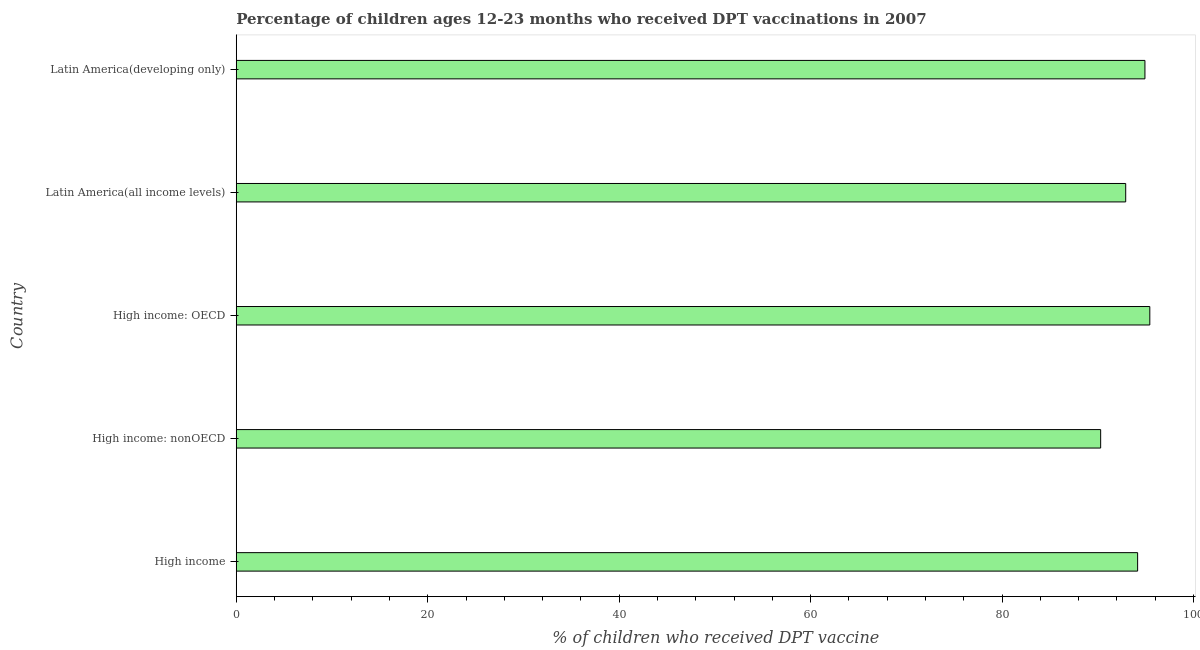Does the graph contain any zero values?
Ensure brevity in your answer.  No. Does the graph contain grids?
Ensure brevity in your answer.  No. What is the title of the graph?
Your response must be concise. Percentage of children ages 12-23 months who received DPT vaccinations in 2007. What is the label or title of the X-axis?
Make the answer very short. % of children who received DPT vaccine. What is the percentage of children who received dpt vaccine in High income: nonOECD?
Provide a succinct answer. 90.29. Across all countries, what is the maximum percentage of children who received dpt vaccine?
Provide a short and direct response. 95.43. Across all countries, what is the minimum percentage of children who received dpt vaccine?
Make the answer very short. 90.29. In which country was the percentage of children who received dpt vaccine maximum?
Your answer should be very brief. High income: OECD. In which country was the percentage of children who received dpt vaccine minimum?
Your response must be concise. High income: nonOECD. What is the sum of the percentage of children who received dpt vaccine?
Keep it short and to the point. 467.71. What is the difference between the percentage of children who received dpt vaccine in High income: OECD and Latin America(all income levels)?
Your answer should be very brief. 2.52. What is the average percentage of children who received dpt vaccine per country?
Ensure brevity in your answer.  93.54. What is the median percentage of children who received dpt vaccine?
Your response must be concise. 94.16. What is the ratio of the percentage of children who received dpt vaccine in High income: OECD to that in High income: nonOECD?
Give a very brief answer. 1.06. Is the percentage of children who received dpt vaccine in High income: OECD less than that in Latin America(all income levels)?
Your answer should be very brief. No. What is the difference between the highest and the second highest percentage of children who received dpt vaccine?
Ensure brevity in your answer.  0.51. What is the difference between the highest and the lowest percentage of children who received dpt vaccine?
Provide a short and direct response. 5.14. In how many countries, is the percentage of children who received dpt vaccine greater than the average percentage of children who received dpt vaccine taken over all countries?
Your response must be concise. 3. How many countries are there in the graph?
Your answer should be compact. 5. What is the difference between two consecutive major ticks on the X-axis?
Give a very brief answer. 20. Are the values on the major ticks of X-axis written in scientific E-notation?
Give a very brief answer. No. What is the % of children who received DPT vaccine of High income?
Offer a very short reply. 94.16. What is the % of children who received DPT vaccine in High income: nonOECD?
Give a very brief answer. 90.29. What is the % of children who received DPT vaccine of High income: OECD?
Your answer should be compact. 95.43. What is the % of children who received DPT vaccine of Latin America(all income levels)?
Ensure brevity in your answer.  92.91. What is the % of children who received DPT vaccine of Latin America(developing only)?
Your answer should be compact. 94.92. What is the difference between the % of children who received DPT vaccine in High income and High income: nonOECD?
Your response must be concise. 3.86. What is the difference between the % of children who received DPT vaccine in High income and High income: OECD?
Offer a very short reply. -1.27. What is the difference between the % of children who received DPT vaccine in High income and Latin America(all income levels)?
Keep it short and to the point. 1.24. What is the difference between the % of children who received DPT vaccine in High income and Latin America(developing only)?
Give a very brief answer. -0.76. What is the difference between the % of children who received DPT vaccine in High income: nonOECD and High income: OECD?
Keep it short and to the point. -5.14. What is the difference between the % of children who received DPT vaccine in High income: nonOECD and Latin America(all income levels)?
Offer a very short reply. -2.62. What is the difference between the % of children who received DPT vaccine in High income: nonOECD and Latin America(developing only)?
Give a very brief answer. -4.63. What is the difference between the % of children who received DPT vaccine in High income: OECD and Latin America(all income levels)?
Keep it short and to the point. 2.52. What is the difference between the % of children who received DPT vaccine in High income: OECD and Latin America(developing only)?
Your answer should be very brief. 0.51. What is the difference between the % of children who received DPT vaccine in Latin America(all income levels) and Latin America(developing only)?
Offer a very short reply. -2.01. What is the ratio of the % of children who received DPT vaccine in High income to that in High income: nonOECD?
Provide a short and direct response. 1.04. What is the ratio of the % of children who received DPT vaccine in High income to that in High income: OECD?
Make the answer very short. 0.99. What is the ratio of the % of children who received DPT vaccine in High income to that in Latin America(all income levels)?
Your answer should be very brief. 1.01. What is the ratio of the % of children who received DPT vaccine in High income to that in Latin America(developing only)?
Provide a short and direct response. 0.99. What is the ratio of the % of children who received DPT vaccine in High income: nonOECD to that in High income: OECD?
Your answer should be compact. 0.95. What is the ratio of the % of children who received DPT vaccine in High income: nonOECD to that in Latin America(developing only)?
Your answer should be very brief. 0.95. What is the ratio of the % of children who received DPT vaccine in High income: OECD to that in Latin America(developing only)?
Offer a very short reply. 1. 